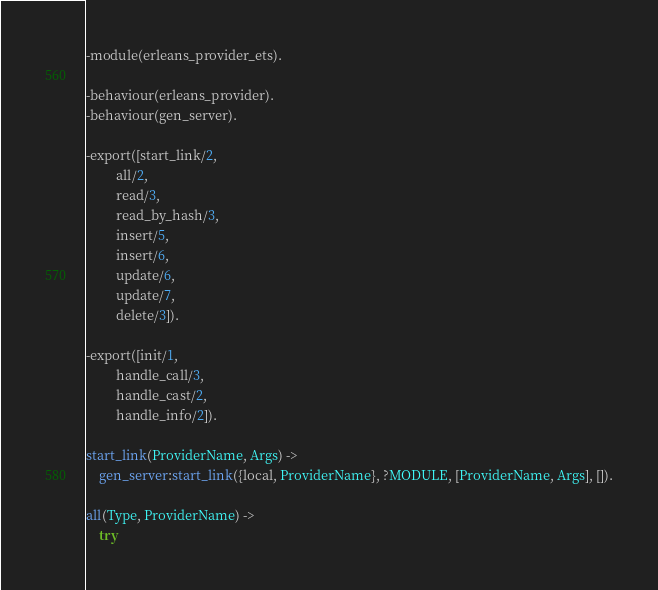<code> <loc_0><loc_0><loc_500><loc_500><_Erlang_>-module(erleans_provider_ets).

-behaviour(erleans_provider).
-behaviour(gen_server).

-export([start_link/2,
         all/2,
         read/3,
         read_by_hash/3,
         insert/5,
         insert/6,
         update/6,
         update/7,
         delete/3]).

-export([init/1,
         handle_call/3,
         handle_cast/2,
         handle_info/2]).

start_link(ProviderName, Args) ->
    gen_server:start_link({local, ProviderName}, ?MODULE, [ProviderName, Args], []).

all(Type, ProviderName) ->
    try</code> 